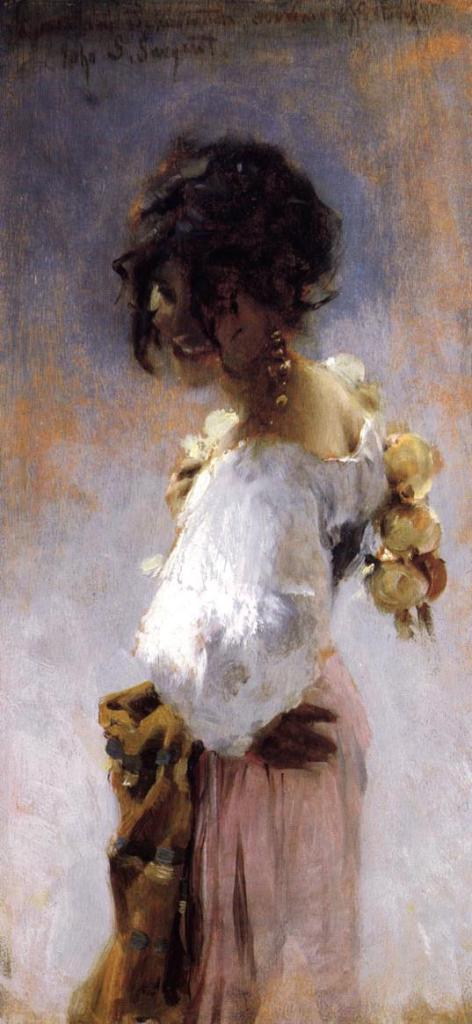How would you summarize this image in a sentence or two? This image is a painting. In this painting we can see a lady. In the background there is a wall. 